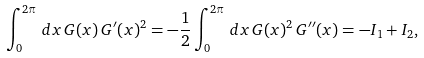Convert formula to latex. <formula><loc_0><loc_0><loc_500><loc_500>\int _ { 0 } ^ { 2 \pi } \, d x \, G ( x ) \, G ^ { \prime } ( x ) ^ { 2 } = - \frac { 1 } { 2 } \int _ { 0 } ^ { 2 \pi } \, d x \, G ( x ) ^ { 2 } \, G ^ { \prime \prime } ( x ) = - I _ { 1 } + I _ { 2 } ,</formula> 